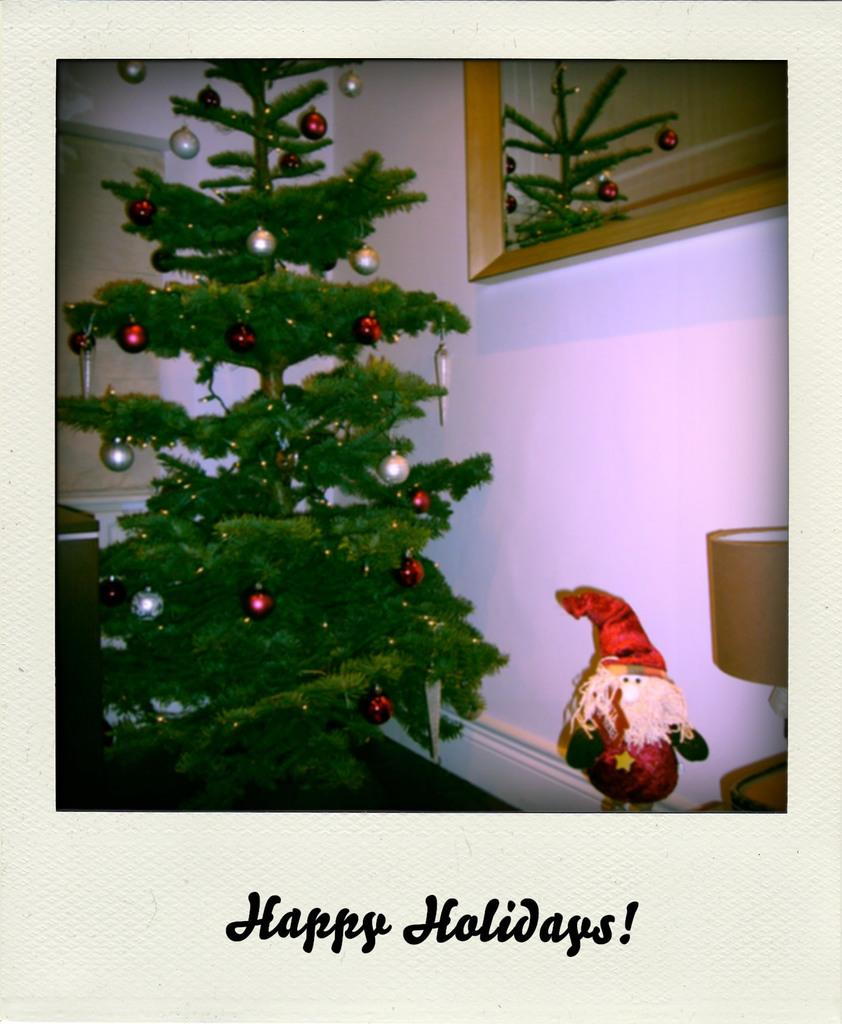What type of tree is in the image? There is a Christmas tree in the image. What decorations are on the Christmas tree? The Christmas tree has balls on it. What is located on the right side of the image? There is a doll and a lamp on the right side of the image. What objects can be seen in the background of the image? There is a mirror and a window in the background of the image. Can you see any mice playing chess on the Christmas tree in the image? No, there are no mice or chess game present on the Christmas tree in the image. 